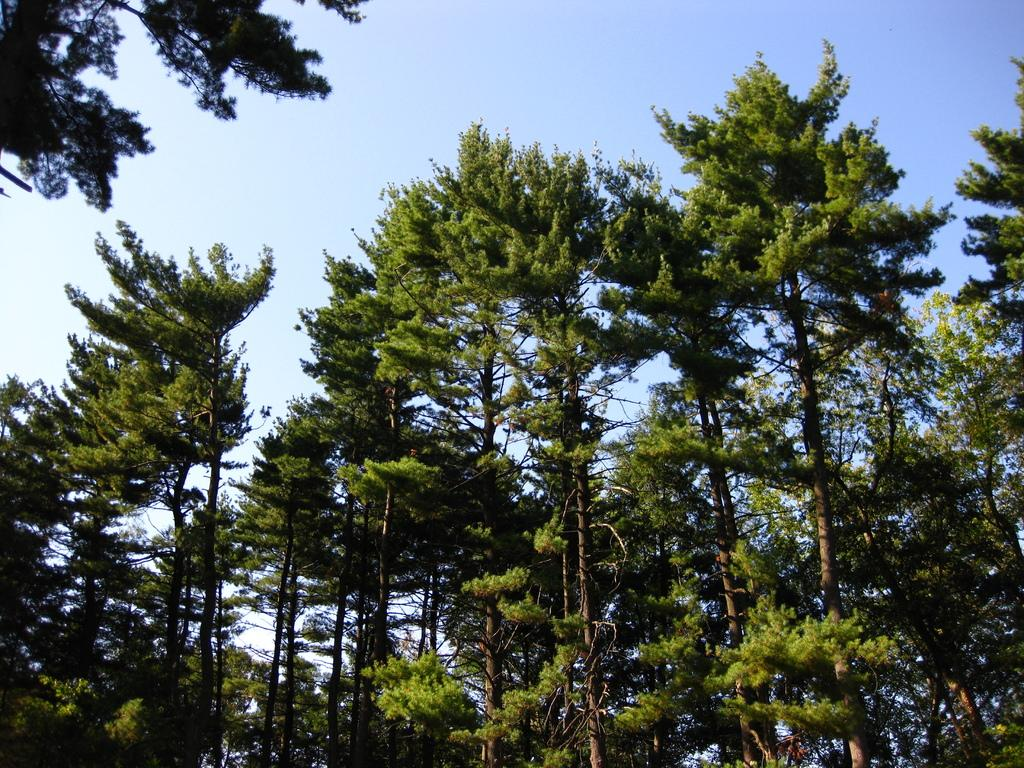What type of vegetation can be seen in the image? There are trees in the image, extending from left to right. What is the color of the sky in the image? The sky is blue in color. What book is being delivered by the parcel service in the image? There is no book or parcel service present in the image; it only features trees and a blue sky. What type of earth is visible in the image? The image does not show any specific type of earth; it only features trees and a blue sky. 